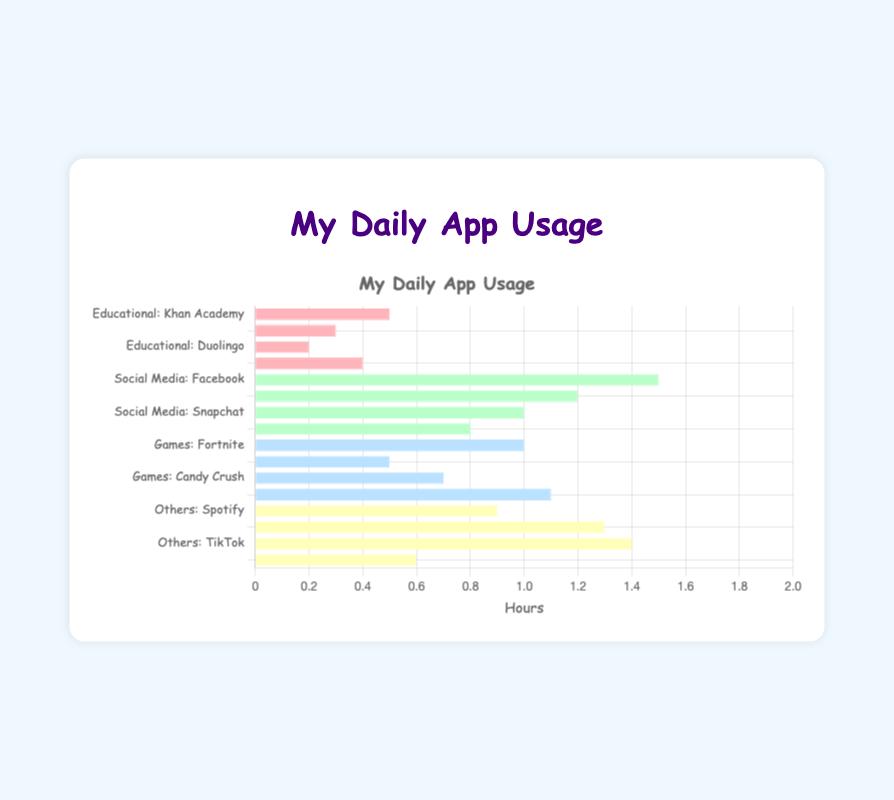Which application has the highest average daily usage? The application with the highest average daily usage is the tallest bar. TikTok has the longest bar with 1.4 hours.
Answer: TikTok How many hours is the combined daily usage of all social media applications? Add the daily usage hours of all social media applications: Facebook (1.5) + Instagram (1.2) + Snapchat (1.0) + Twitter (0.8) = 4.5 hours.
Answer: 4.5 Which category has the most varied usage times, and which has the least? By inspecting the length of the bars, Social Media has the most varied usage times ranging from 0.8 to 1.5 hours. Educational has the least variation, ranging from 0.2 to 0.5 hours.
Answer: Most varied: Social Media, Least varied: Educational How does the usage of Khan Academy compare to Spotify? Compare the bar lengths of Khan Academy (0.5 hours) and Spotify (0.9 hours). Spotify's bar is longer.
Answer: Spotify > Khan Academy What is the total screen time for educational applications per day? Sum the daily usage hours for all educational applications: Khan Academy (0.5) + Coursera (0.3) + Duolingo (0.2) + TED (0.4) = 1.4 hours.
Answer: 1.4 Which two applications have exactly the same average daily usage and what is that usage? The bars for Snapchat and Fortnite have the same length, indicating they both have an average daily usage of 1.0 hours.
Answer: Snapchat, Fortnite: 1.0 hours Which category has the highest average daily usage on aggregate (sum of all applications within that category)? Calculate the sum for each category: Educational (1.4), Social Media (4.5), Games (3.3), Others (4.2). Social Media has the highest aggregate.
Answer: Social Media Is the daily usage of Reddit higher or lower than Duolingo? Compare the bar lengths of Reddit (0.6 hours) and Duolingo (0.2 hours). Reddit's bar is longer.
Answer: Reddit > Duolingo What is the difference in usage hours between the most and least used applications in the 'Others' category? Subtract the smallest usage in 'Others' (Reddit 0.6) from the largest (TikTok 1.4): 1.4 - 0.6 = 0.8 hours.
Answer: 0.8 Which category uses the least screen time for the most daily-used application within that category? The most used applications per category: Educational (Khan Academy 0.5), Social Media (Facebook 1.5), Games (Minecraft 1.1), Others (TikTok 1.4). The least is Khan Academy with 0.5 hours.
Answer: Educational (Khan Academy) 